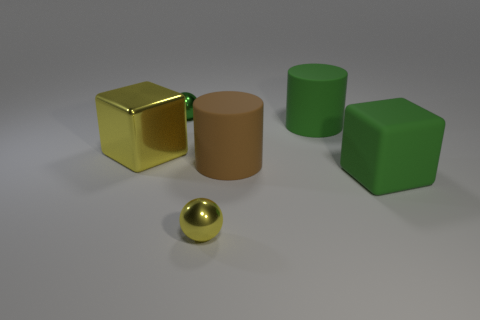Add 3 brown rubber things. How many objects exist? 9 Subtract 1 cylinders. How many cylinders are left? 1 Subtract all gray cubes. Subtract all cyan balls. How many cubes are left? 2 Subtract all brown cylinders. How many yellow blocks are left? 1 Subtract all small green shiny spheres. Subtract all tiny green things. How many objects are left? 4 Add 3 cylinders. How many cylinders are left? 5 Add 5 red cylinders. How many red cylinders exist? 5 Subtract all yellow spheres. How many spheres are left? 1 Subtract 1 yellow spheres. How many objects are left? 5 Subtract all cylinders. How many objects are left? 4 